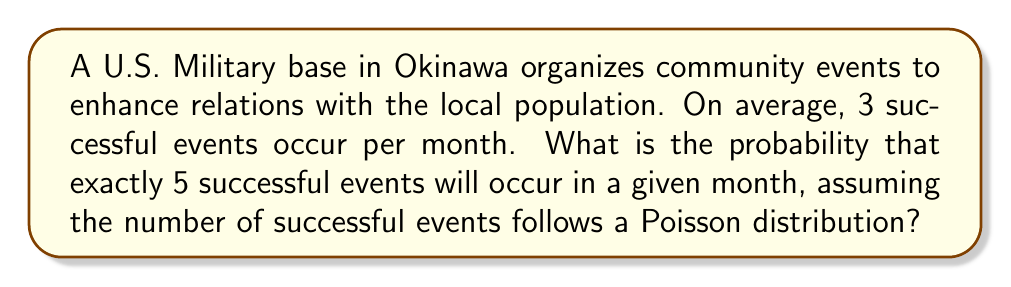What is the answer to this math problem? To solve this problem, we'll use the Poisson distribution formula:

$$P(X = k) = \frac{e^{-\lambda} \lambda^k}{k!}$$

Where:
$\lambda$ = average rate of events
$k$ = number of events we're interested in
$e$ = Euler's number (approximately 2.71828)

Given:
$\lambda = 3$ (average of 3 successful events per month)
$k = 5$ (we want exactly 5 successful events)

Step 1: Plug the values into the formula
$$P(X = 5) = \frac{e^{-3} 3^5}{5!}$$

Step 2: Calculate $3^5$
$$3^5 = 243$$

Step 3: Calculate $5!$
$$5! = 5 \times 4 \times 3 \times 2 \times 1 = 120$$

Step 4: Calculate $e^{-3}$
$$e^{-3} \approx 0.0497871$$

Step 5: Put it all together and calculate
$$P(X = 5) = \frac{0.0497871 \times 243}{120} \approx 0.1008$$

Therefore, the probability of exactly 5 successful events occurring in a given month is approximately 0.1008 or 10.08%.
Answer: 0.1008 